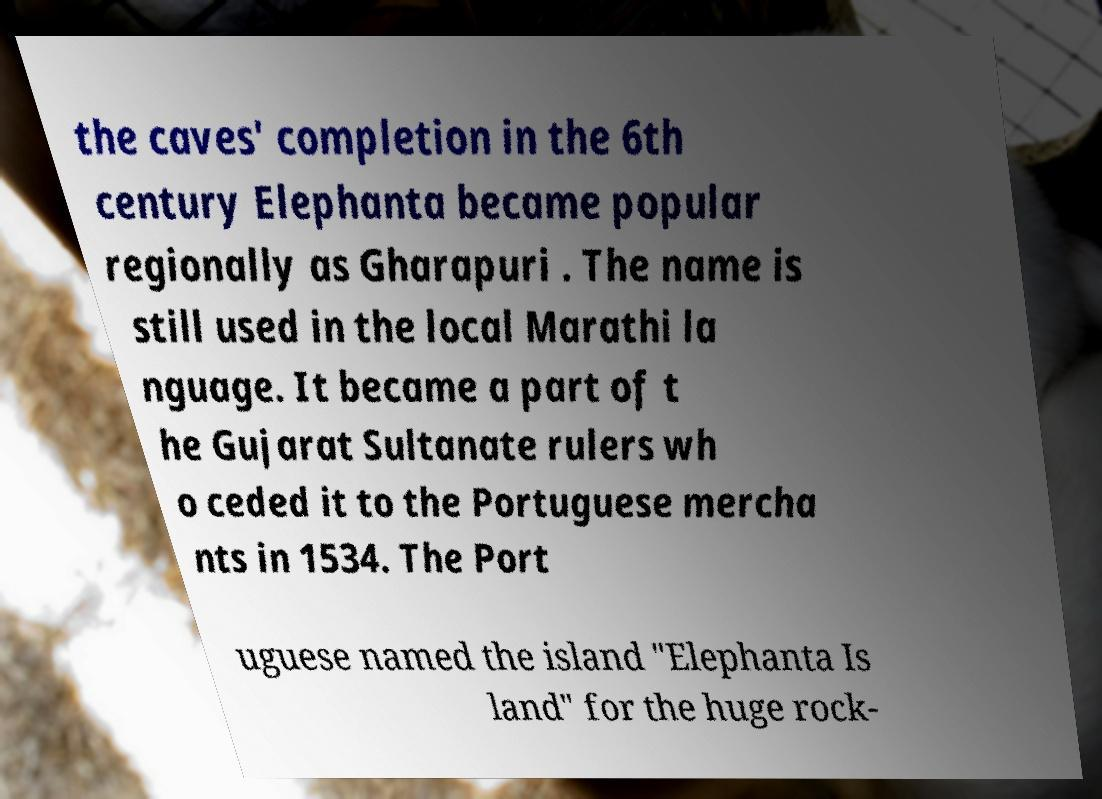What messages or text are displayed in this image? I need them in a readable, typed format. the caves' completion in the 6th century Elephanta became popular regionally as Gharapuri . The name is still used in the local Marathi la nguage. It became a part of t he Gujarat Sultanate rulers wh o ceded it to the Portuguese mercha nts in 1534. The Port uguese named the island "Elephanta Is land" for the huge rock- 